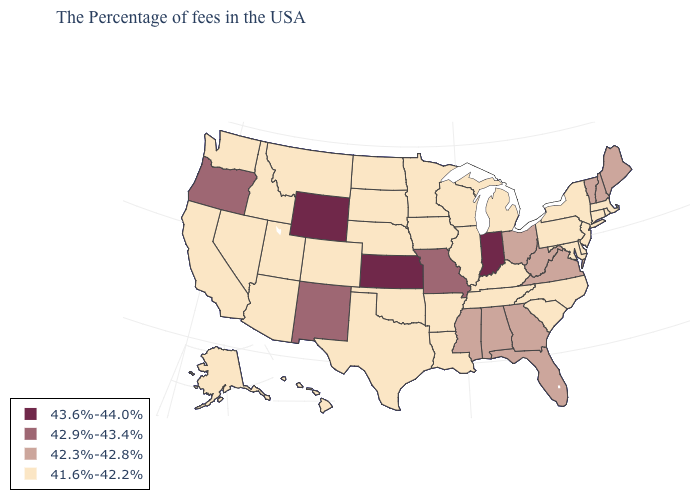What is the value of Minnesota?
Write a very short answer. 41.6%-42.2%. What is the value of Pennsylvania?
Answer briefly. 41.6%-42.2%. Is the legend a continuous bar?
Give a very brief answer. No. Which states have the lowest value in the USA?
Write a very short answer. Massachusetts, Rhode Island, Connecticut, New York, New Jersey, Delaware, Maryland, Pennsylvania, North Carolina, South Carolina, Michigan, Kentucky, Tennessee, Wisconsin, Illinois, Louisiana, Arkansas, Minnesota, Iowa, Nebraska, Oklahoma, Texas, South Dakota, North Dakota, Colorado, Utah, Montana, Arizona, Idaho, Nevada, California, Washington, Alaska, Hawaii. Does Arkansas have the lowest value in the USA?
Concise answer only. Yes. Name the states that have a value in the range 41.6%-42.2%?
Give a very brief answer. Massachusetts, Rhode Island, Connecticut, New York, New Jersey, Delaware, Maryland, Pennsylvania, North Carolina, South Carolina, Michigan, Kentucky, Tennessee, Wisconsin, Illinois, Louisiana, Arkansas, Minnesota, Iowa, Nebraska, Oklahoma, Texas, South Dakota, North Dakota, Colorado, Utah, Montana, Arizona, Idaho, Nevada, California, Washington, Alaska, Hawaii. Name the states that have a value in the range 41.6%-42.2%?
Answer briefly. Massachusetts, Rhode Island, Connecticut, New York, New Jersey, Delaware, Maryland, Pennsylvania, North Carolina, South Carolina, Michigan, Kentucky, Tennessee, Wisconsin, Illinois, Louisiana, Arkansas, Minnesota, Iowa, Nebraska, Oklahoma, Texas, South Dakota, North Dakota, Colorado, Utah, Montana, Arizona, Idaho, Nevada, California, Washington, Alaska, Hawaii. What is the lowest value in the Northeast?
Quick response, please. 41.6%-42.2%. Which states have the lowest value in the West?
Be succinct. Colorado, Utah, Montana, Arizona, Idaho, Nevada, California, Washington, Alaska, Hawaii. Name the states that have a value in the range 41.6%-42.2%?
Short answer required. Massachusetts, Rhode Island, Connecticut, New York, New Jersey, Delaware, Maryland, Pennsylvania, North Carolina, South Carolina, Michigan, Kentucky, Tennessee, Wisconsin, Illinois, Louisiana, Arkansas, Minnesota, Iowa, Nebraska, Oklahoma, Texas, South Dakota, North Dakota, Colorado, Utah, Montana, Arizona, Idaho, Nevada, California, Washington, Alaska, Hawaii. Name the states that have a value in the range 42.9%-43.4%?
Keep it brief. Missouri, New Mexico, Oregon. Which states have the highest value in the USA?
Keep it brief. Indiana, Kansas, Wyoming. What is the value of Indiana?
Answer briefly. 43.6%-44.0%. What is the value of Rhode Island?
Be succinct. 41.6%-42.2%. Among the states that border Maryland , does Delaware have the highest value?
Quick response, please. No. 